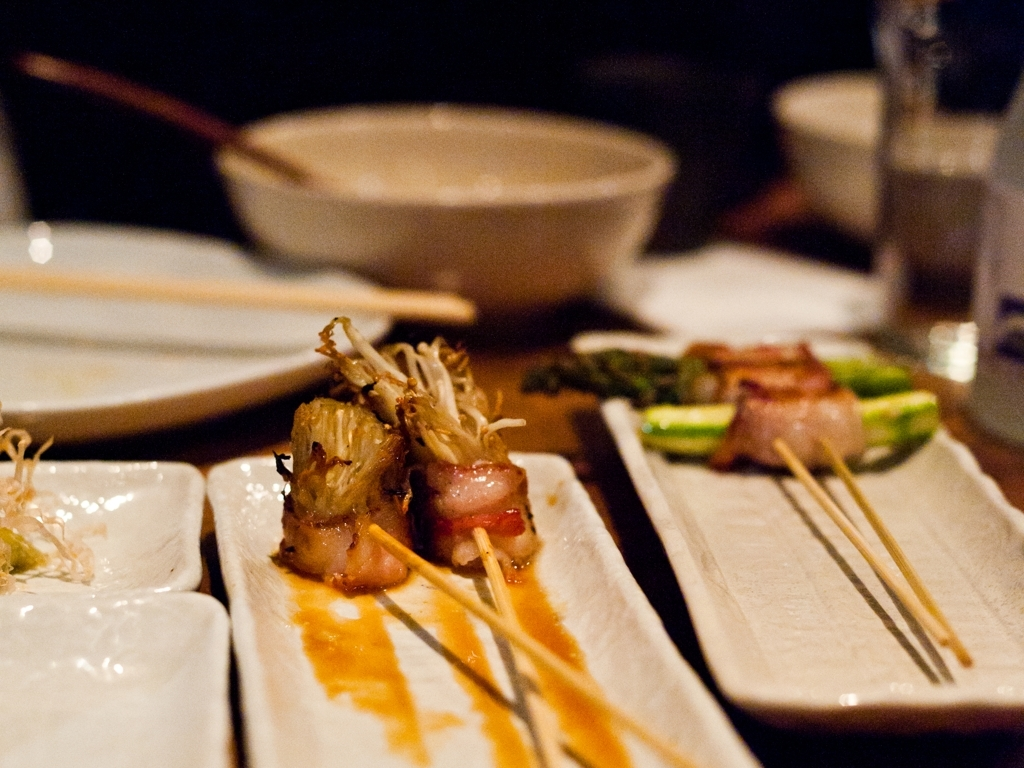Can you describe the dish presented in the foreground? The dish in the foreground appears to be a gourmet appetizer, featuring skewered enoki mushrooms, wrapped in what could be a slice of bacon, served with an artistic drizzle of a glaze which might be a reduction of soy or teriyaki sauce. Does it look like a dish from a particular cuisine? Given the presentation and ingredients like enoki mushrooms and the possible use of a soy-based glaze, this dish likely takes inspiration from Japanese cuisine, known for its delicate flavors and emphasis on presentation. 